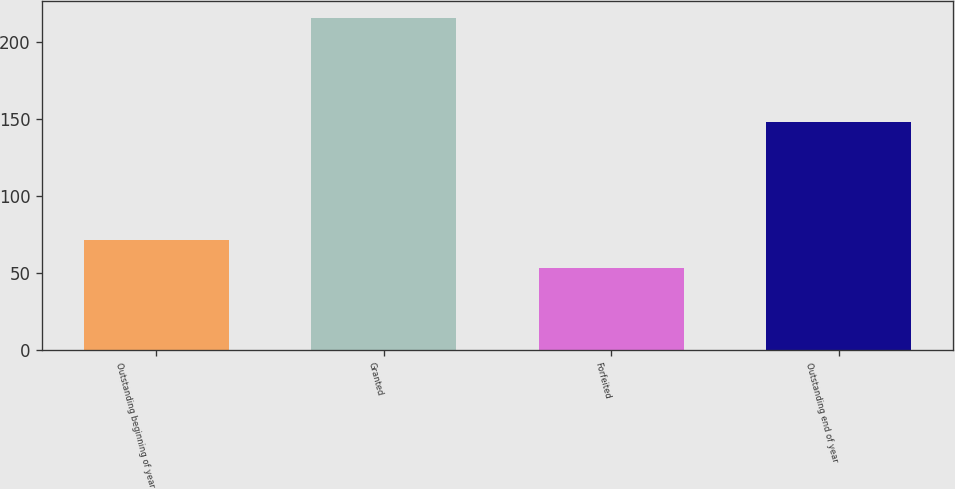<chart> <loc_0><loc_0><loc_500><loc_500><bar_chart><fcel>Outstanding beginning of year<fcel>Granted<fcel>Forfeited<fcel>Outstanding end of year<nl><fcel>71.03<fcel>215.76<fcel>53.36<fcel>148.22<nl></chart> 